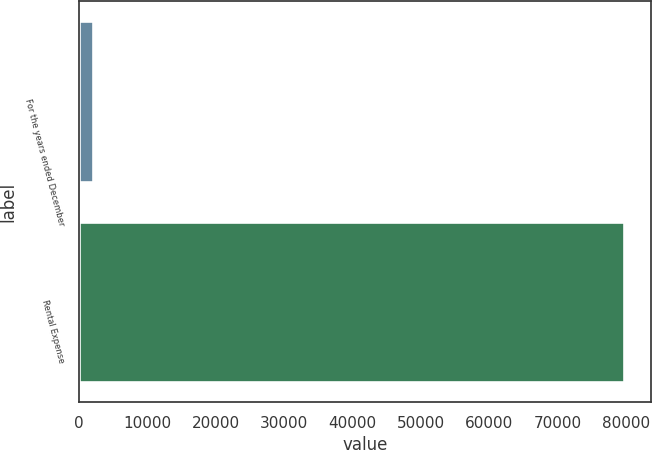Convert chart. <chart><loc_0><loc_0><loc_500><loc_500><bar_chart><fcel>For the years ended December<fcel>Rental Expense<nl><fcel>2018<fcel>79631<nl></chart> 